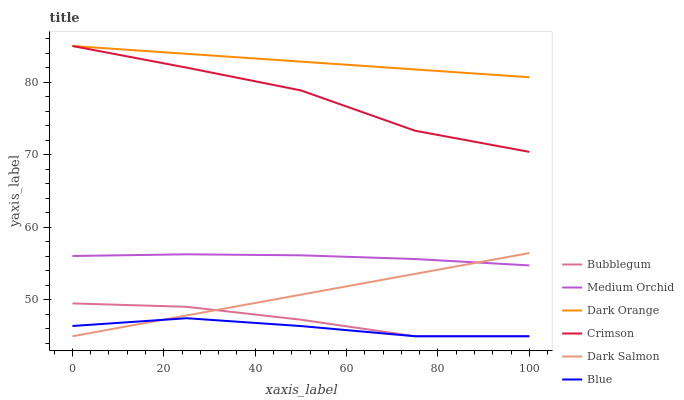Does Blue have the minimum area under the curve?
Answer yes or no. Yes. Does Dark Orange have the maximum area under the curve?
Answer yes or no. Yes. Does Medium Orchid have the minimum area under the curve?
Answer yes or no. No. Does Medium Orchid have the maximum area under the curve?
Answer yes or no. No. Is Dark Salmon the smoothest?
Answer yes or no. Yes. Is Crimson the roughest?
Answer yes or no. Yes. Is Dark Orange the smoothest?
Answer yes or no. No. Is Dark Orange the roughest?
Answer yes or no. No. Does Blue have the lowest value?
Answer yes or no. Yes. Does Medium Orchid have the lowest value?
Answer yes or no. No. Does Crimson have the highest value?
Answer yes or no. Yes. Does Medium Orchid have the highest value?
Answer yes or no. No. Is Blue less than Dark Orange?
Answer yes or no. Yes. Is Crimson greater than Blue?
Answer yes or no. Yes. Does Dark Salmon intersect Medium Orchid?
Answer yes or no. Yes. Is Dark Salmon less than Medium Orchid?
Answer yes or no. No. Is Dark Salmon greater than Medium Orchid?
Answer yes or no. No. Does Blue intersect Dark Orange?
Answer yes or no. No. 